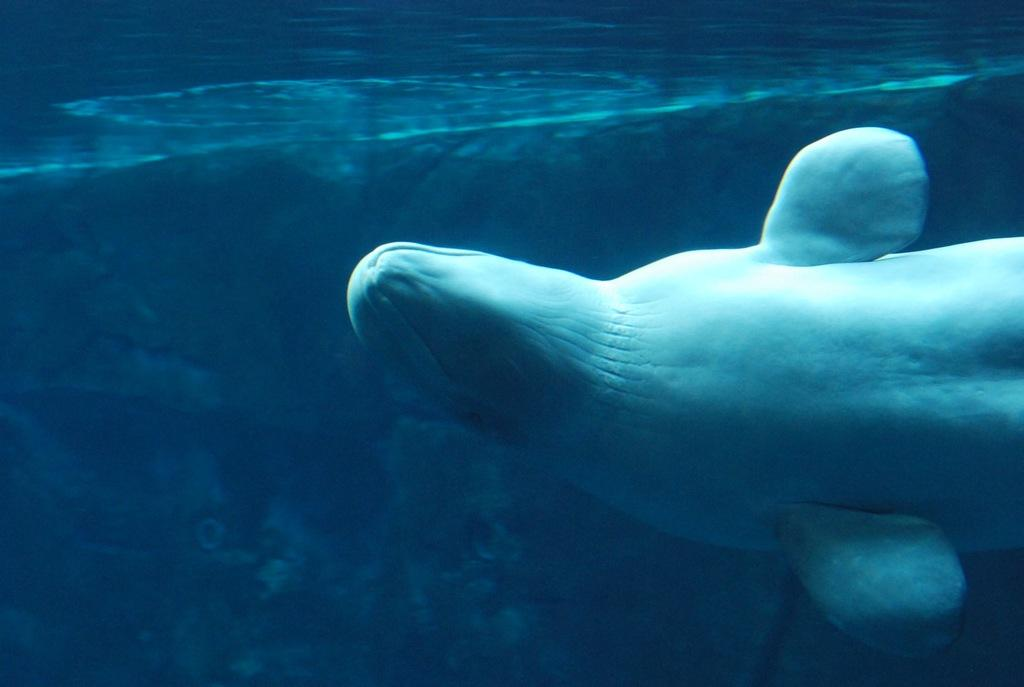What type of animal can be seen in the image? There is an aquatic animal in the image. What color is the water surrounding the animal? The water in the image is blue. What type of scissors can be seen cutting through the water in the image? There are no scissors present in the image; it features an aquatic animal in blue water. How does the animal grip the water in the image? The image does not show the animal gripping the water, as it is a still image. 